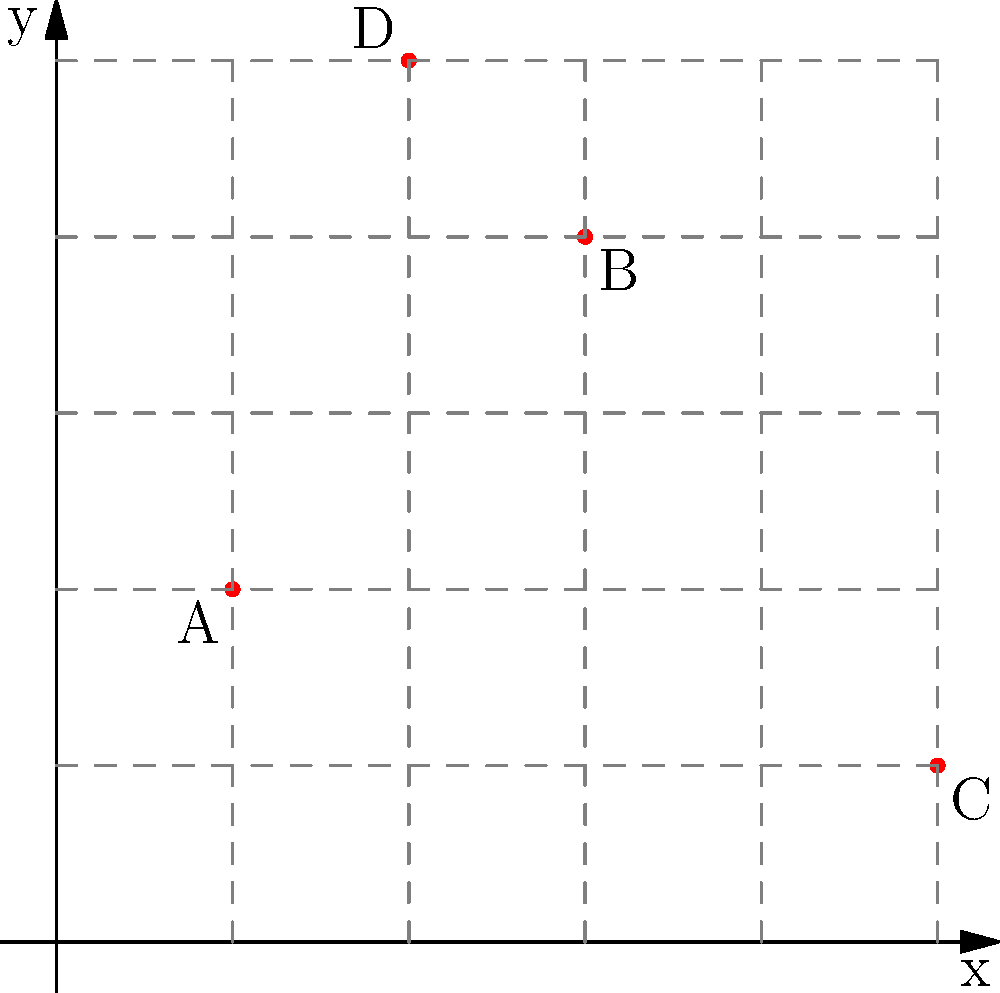As part of your community service project, you're mapping local food banks on a coordinate grid. Four food banks (A, B, C, and D) are shown on the grid. If you want to visit all four food banks starting from the origin (0,0) and ending at food bank C, what is the total distance you would travel in grid units, assuming you can only move horizontally or vertically? Let's approach this step-by-step:

1. First, we need to identify the coordinates of each food bank:
   A: (1, 2)
   B: (3, 4)
   C: (5, 1)
   D: (2, 5)

2. Now, let's calculate the distance for each leg of the journey:
   
   a) From (0, 0) to A (1, 2):
      Distance = |1 - 0| + |2 - 0| = 1 + 2 = 3 units
   
   b) From A (1, 2) to D (2, 5):
      Distance = |2 - 1| + |5 - 2| = 1 + 3 = 4 units
   
   c) From D (2, 5) to B (3, 4):
      Distance = |3 - 2| + |4 - 5| = 1 + 1 = 2 units
   
   d) From B (3, 4) to C (5, 1):
      Distance = |5 - 3| + |1 - 4| = 2 + 3 = 5 units

3. To get the total distance, we sum up all these individual distances:
   Total distance = 3 + 4 + 2 + 5 = 14 units

Therefore, the total distance traveled is 14 grid units.
Answer: 14 units 